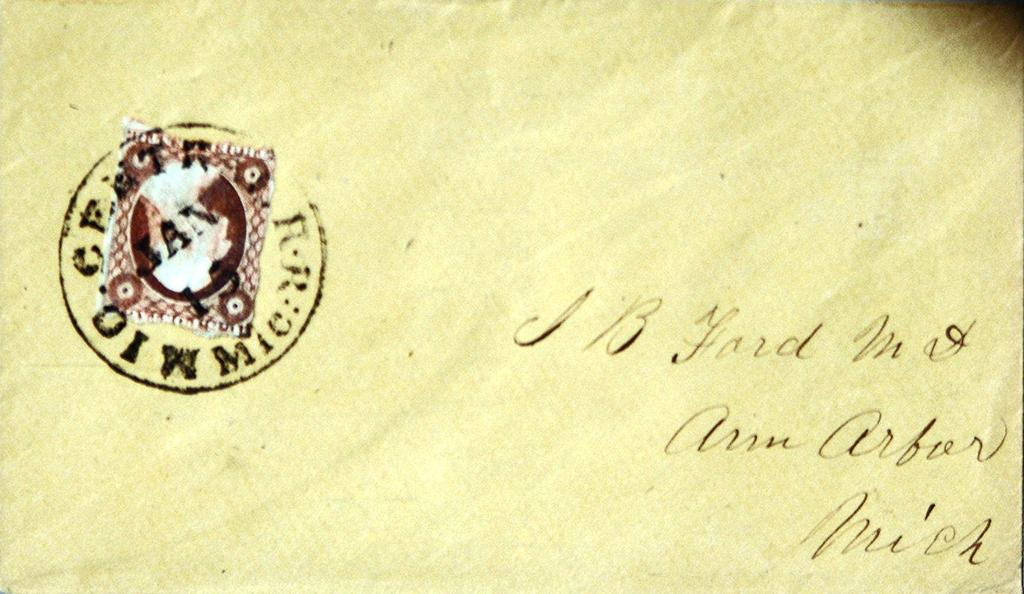<image>
Provide a brief description of the given image. A letter with J B Ford written on it in cursive. 